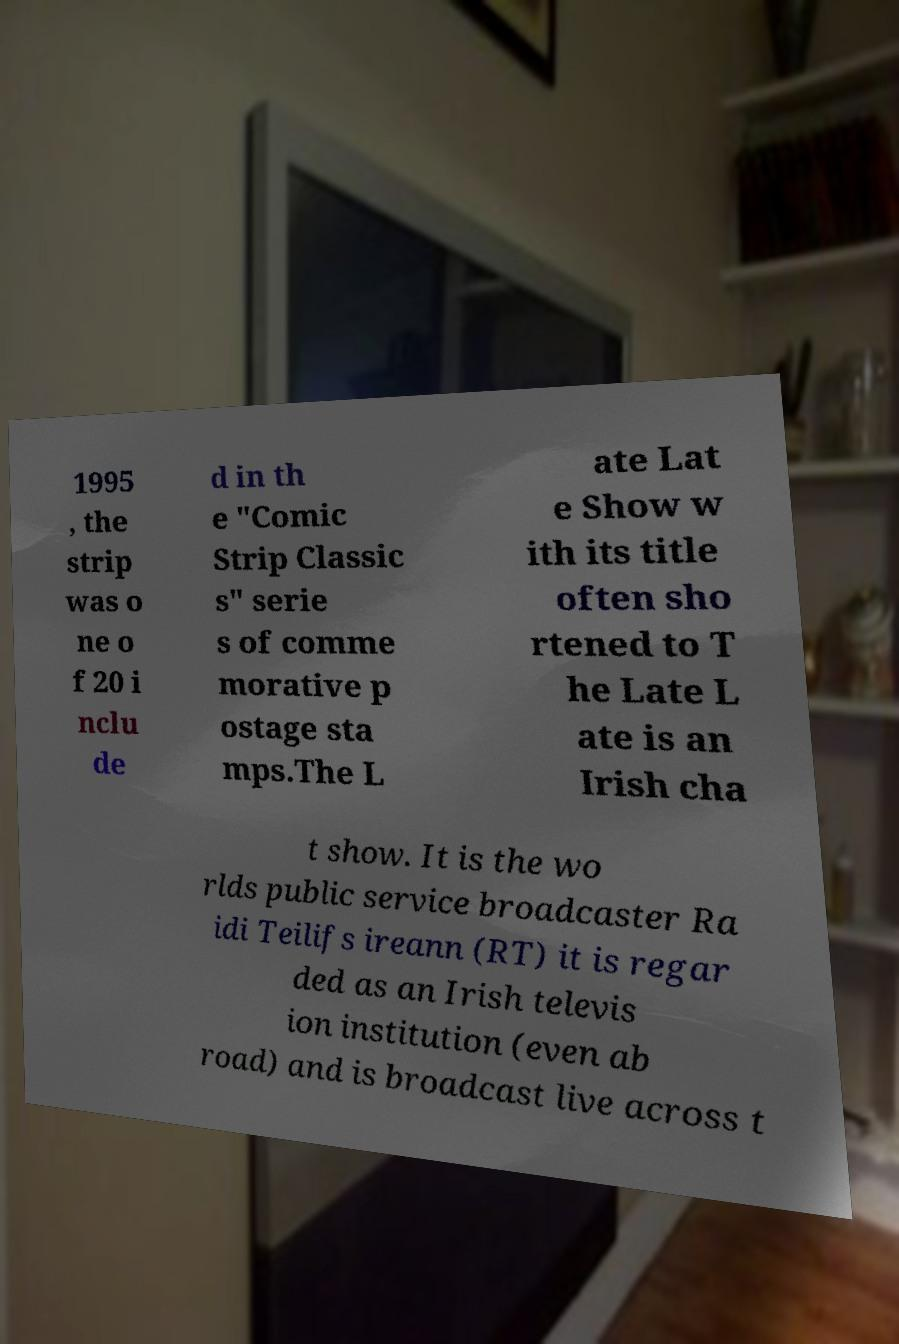Please read and relay the text visible in this image. What does it say? 1995 , the strip was o ne o f 20 i nclu de d in th e "Comic Strip Classic s" serie s of comme morative p ostage sta mps.The L ate Lat e Show w ith its title often sho rtened to T he Late L ate is an Irish cha t show. It is the wo rlds public service broadcaster Ra idi Teilifs ireann (RT) it is regar ded as an Irish televis ion institution (even ab road) and is broadcast live across t 